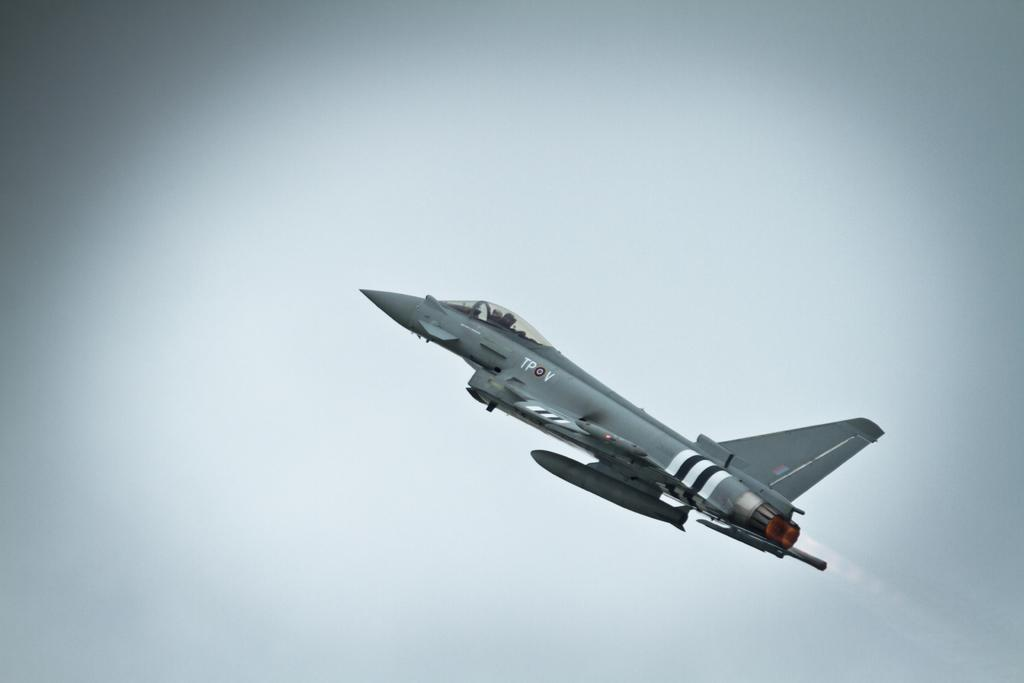What is the main subject of the image? The main subject of the image is an aircraft. Where is the aircraft located in the image? The aircraft is in the sky. What type of crime is being committed by the aircraft in the image? There is no crime being committed by the aircraft in the image; it is simply an aircraft in the sky. What type of skirt is visible on the aircraft in the image? There is no skirt present on the aircraft in the image. 